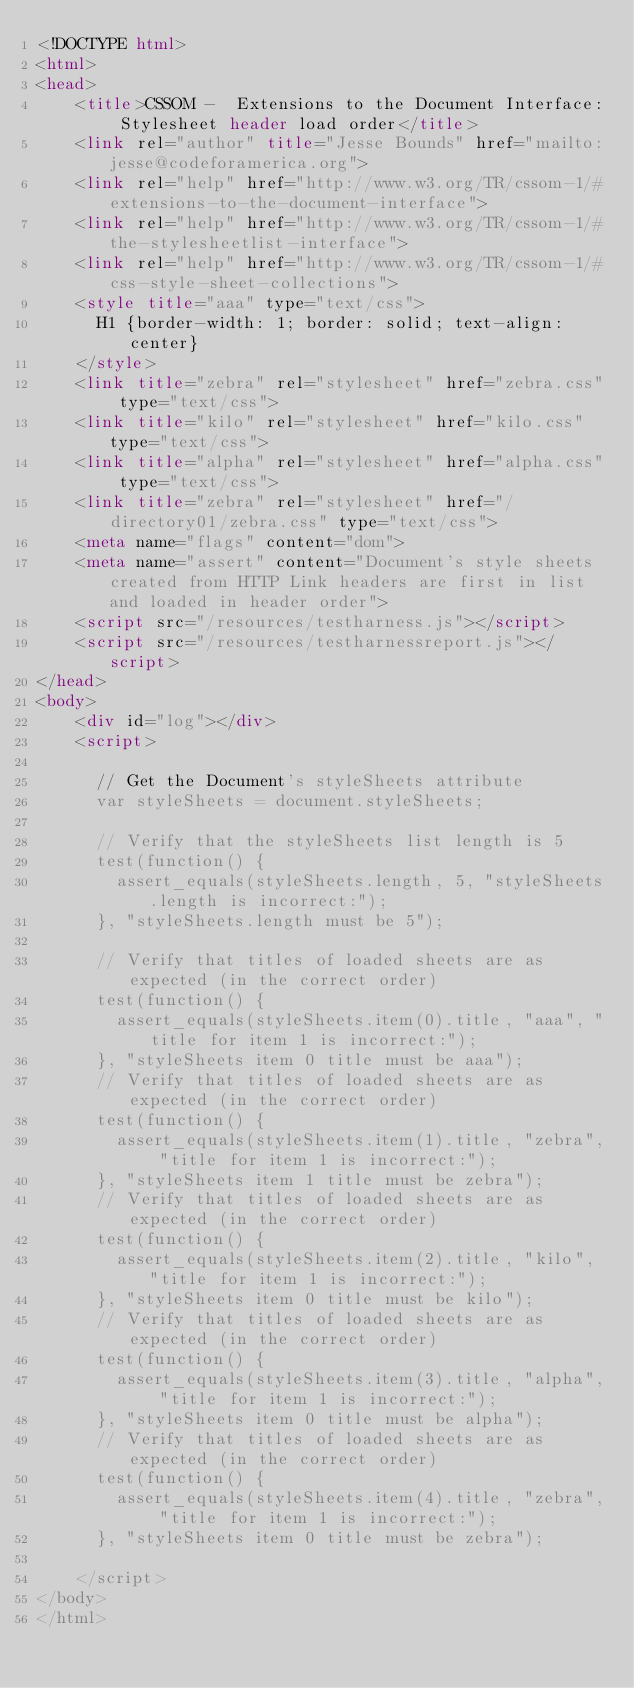<code> <loc_0><loc_0><loc_500><loc_500><_HTML_><!DOCTYPE html>
<html>
<head>
    <title>CSSOM -  Extensions to the Document Interface: Stylesheet header load order</title>
    <link rel="author" title="Jesse Bounds" href="mailto:jesse@codeforamerica.org">
    <link rel="help" href="http://www.w3.org/TR/cssom-1/#extensions-to-the-document-interface">
    <link rel="help" href="http://www.w3.org/TR/cssom-1/#the-stylesheetlist-interface">
    <link rel="help" href="http://www.w3.org/TR/cssom-1/#css-style-sheet-collections">
    <style title="aaa" type="text/css">
      H1 {border-width: 1; border: solid; text-align: center}
    </style>
    <link title="zebra" rel="stylesheet" href="zebra.css" type="text/css">
    <link title="kilo" rel="stylesheet" href="kilo.css"  type="text/css">
    <link title="alpha" rel="stylesheet" href="alpha.css" type="text/css">
    <link title="zebra" rel="stylesheet" href="/directory01/zebra.css" type="text/css">
    <meta name="flags" content="dom">
    <meta name="assert" content="Document's style sheets created from HTTP Link headers are first in list and loaded in header order">
    <script src="/resources/testharness.js"></script>
    <script src="/resources/testharnessreport.js"></script>
</head>
<body>
    <div id="log"></div>
    <script>

      // Get the Document's styleSheets attribute
      var styleSheets = document.styleSheets;

      // Verify that the styleSheets list length is 5
      test(function() {
        assert_equals(styleSheets.length, 5, "styleSheets.length is incorrect:");
      }, "styleSheets.length must be 5");

      // Verify that titles of loaded sheets are as expected (in the correct order)
      test(function() {
        assert_equals(styleSheets.item(0).title, "aaa", "title for item 1 is incorrect:");
      }, "styleSheets item 0 title must be aaa");
      // Verify that titles of loaded sheets are as expected (in the correct order)
      test(function() {
        assert_equals(styleSheets.item(1).title, "zebra", "title for item 1 is incorrect:");
      }, "styleSheets item 1 title must be zebra");
      // Verify that titles of loaded sheets are as expected (in the correct order)
      test(function() {
        assert_equals(styleSheets.item(2).title, "kilo", "title for item 1 is incorrect:");
      }, "styleSheets item 0 title must be kilo");
      // Verify that titles of loaded sheets are as expected (in the correct order)
      test(function() {
        assert_equals(styleSheets.item(3).title, "alpha", "title for item 1 is incorrect:");
      }, "styleSheets item 0 title must be alpha");
      // Verify that titles of loaded sheets are as expected (in the correct order)
      test(function() {
        assert_equals(styleSheets.item(4).title, "zebra", "title for item 1 is incorrect:");
      }, "styleSheets item 0 title must be zebra");

    </script>
</body>
</html>
</code> 